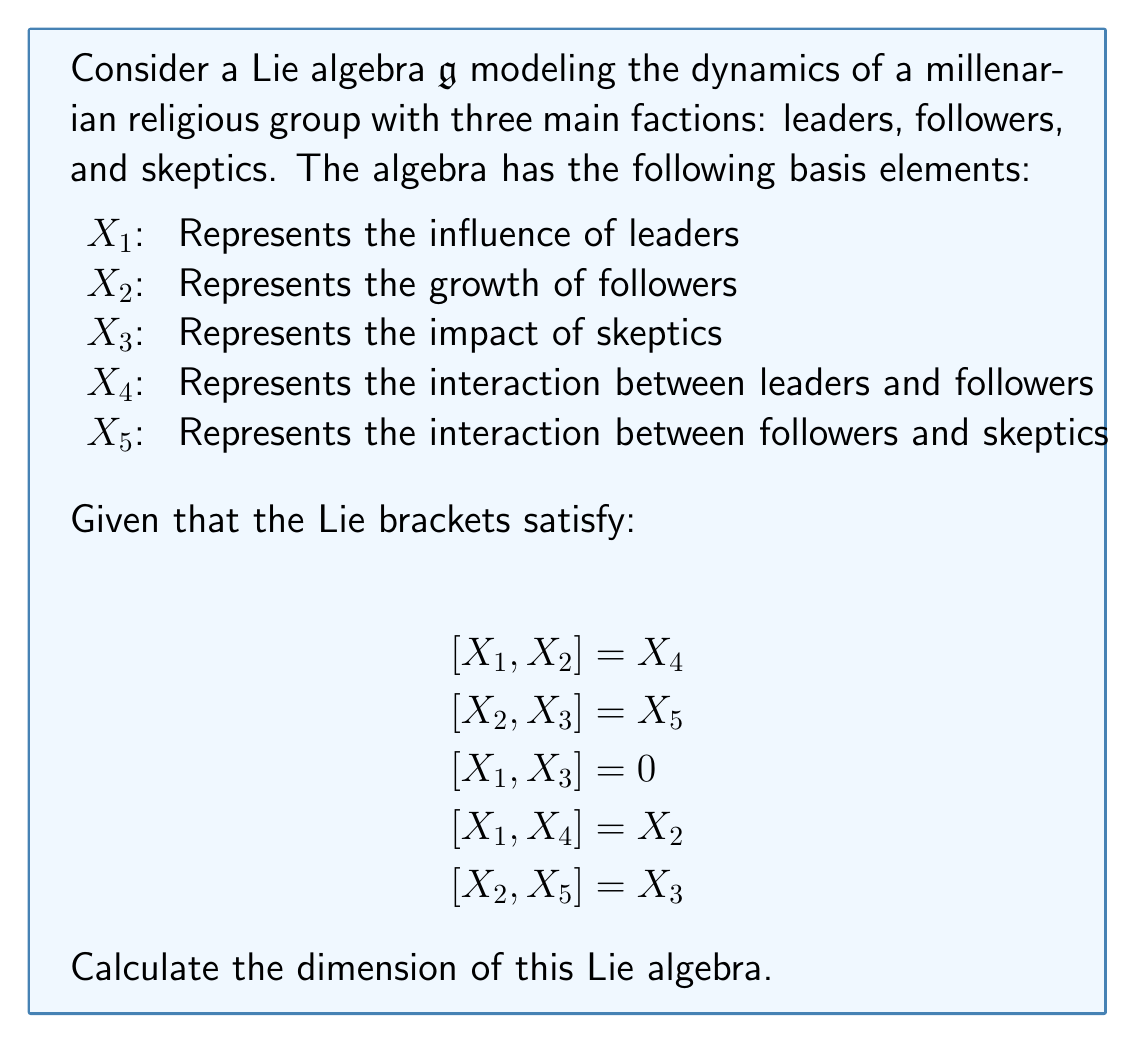Give your solution to this math problem. To determine the dimension of a Lie algebra, we need to count the number of linearly independent basis elements. In this case, we'll analyze the given basis elements and their relationships:

1. We start with five basis elements: $X_1$, $X_2$, $X_3$, $X_4$, and $X_5$.

2. Let's check if any of these elements can be expressed as a linear combination of the others using the given Lie bracket relations:

   a. $[X_1, X_2] = X_4$ implies that $X_4$ is not an additional dimension, as it can be generated by $X_1$ and $X_2$.
   
   b. $[X_2, X_3] = X_5$ implies that $X_5$ is not an additional dimension, as it can be generated by $X_2$ and $X_3$.
   
   c. $[X_1, X_3] = 0$ doesn't introduce any new elements.
   
   d. $[X_1, X_4] = X_2$ doesn't introduce any new elements, as $X_2$ is already in our basis.
   
   e. $[X_2, X_5] = X_3$ doesn't introduce any new elements, as $X_3$ is already in our basis.

3. After analyzing these relations, we can conclude that $X_1$, $X_2$, and $X_3$ form a minimal generating set for the Lie algebra. $X_4$ and $X_5$ can be expressed in terms of these three elements.

4. Therefore, the dimension of the Lie algebra is equal to the number of elements in this minimal generating set.

This Lie algebra structure reflects the dynamics of the millenarian religious group:
- $X_1$ (leaders) and $X_2$ (followers) interact to produce $X_4$
- $X_2$ (followers) and $X_3$ (skeptics) interact to produce $X_5$
- Leaders ($X_1$) and skeptics ($X_3$) don't directly interact
- The influence of leaders ($X_1$) on the leader-follower interaction ($X_4$) produces more followers ($X_2$)
- The interaction of followers with follower-skeptic dynamics ($X_2$ and $X_5$) produces more skeptics ($X_3$)

This model captures the essential dynamics of faction interactions within the religious group.
Answer: The dimension of the Lie algebra is 3. 